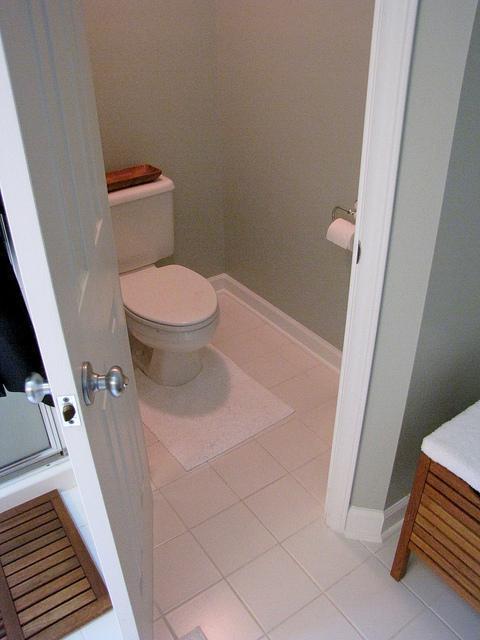How many people are sitting down?
Give a very brief answer. 0. 